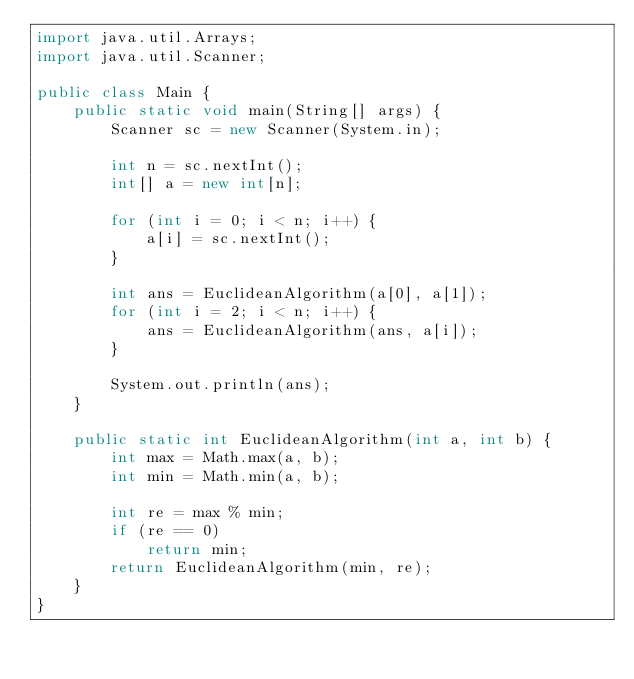<code> <loc_0><loc_0><loc_500><loc_500><_Java_>import java.util.Arrays;
import java.util.Scanner;

public class Main {
    public static void main(String[] args) {
        Scanner sc = new Scanner(System.in);

        int n = sc.nextInt();
        int[] a = new int[n];

        for (int i = 0; i < n; i++) {
            a[i] = sc.nextInt();
        }

        int ans = EuclideanAlgorithm(a[0], a[1]);
        for (int i = 2; i < n; i++) {
            ans = EuclideanAlgorithm(ans, a[i]);
        }

        System.out.println(ans);
    }

    public static int EuclideanAlgorithm(int a, int b) {
        int max = Math.max(a, b);
        int min = Math.min(a, b);

        int re = max % min;
        if (re == 0)
            return min;
        return EuclideanAlgorithm(min, re);
    }
}
</code> 